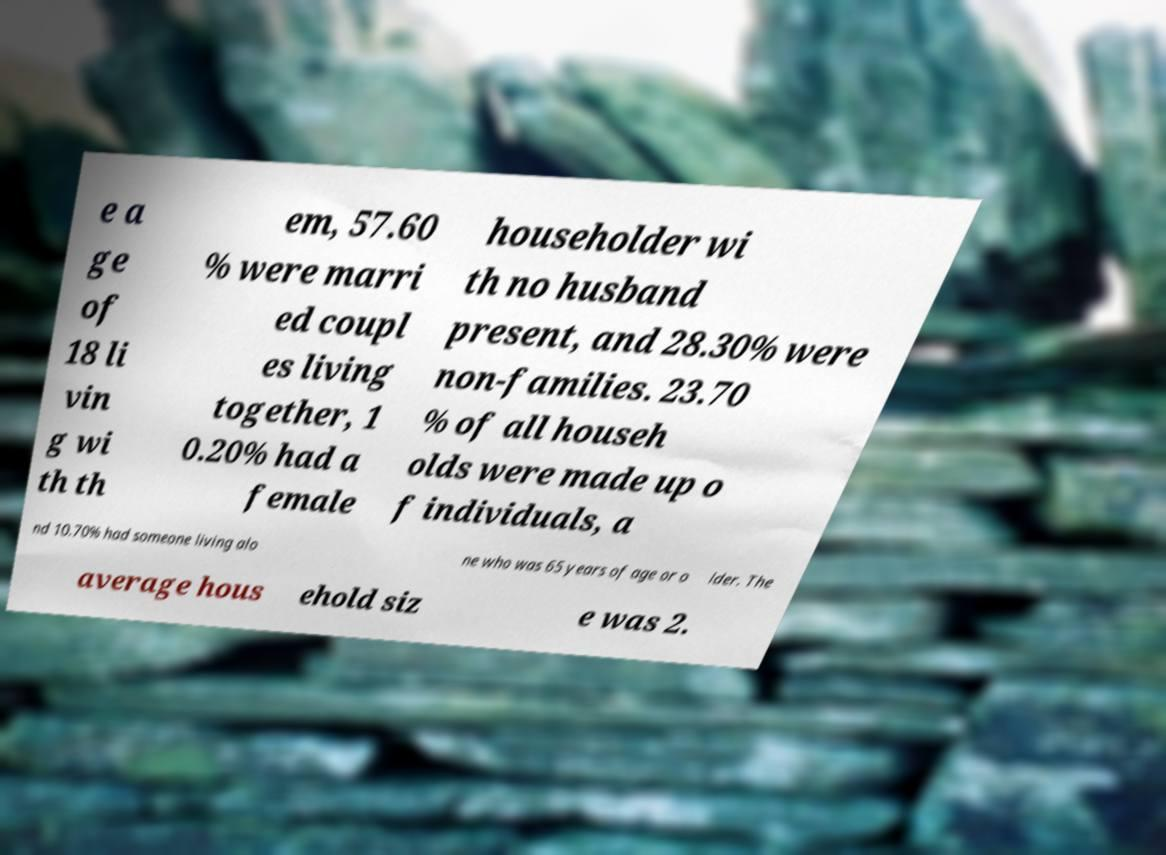There's text embedded in this image that I need extracted. Can you transcribe it verbatim? e a ge of 18 li vin g wi th th em, 57.60 % were marri ed coupl es living together, 1 0.20% had a female householder wi th no husband present, and 28.30% were non-families. 23.70 % of all househ olds were made up o f individuals, a nd 10.70% had someone living alo ne who was 65 years of age or o lder. The average hous ehold siz e was 2. 